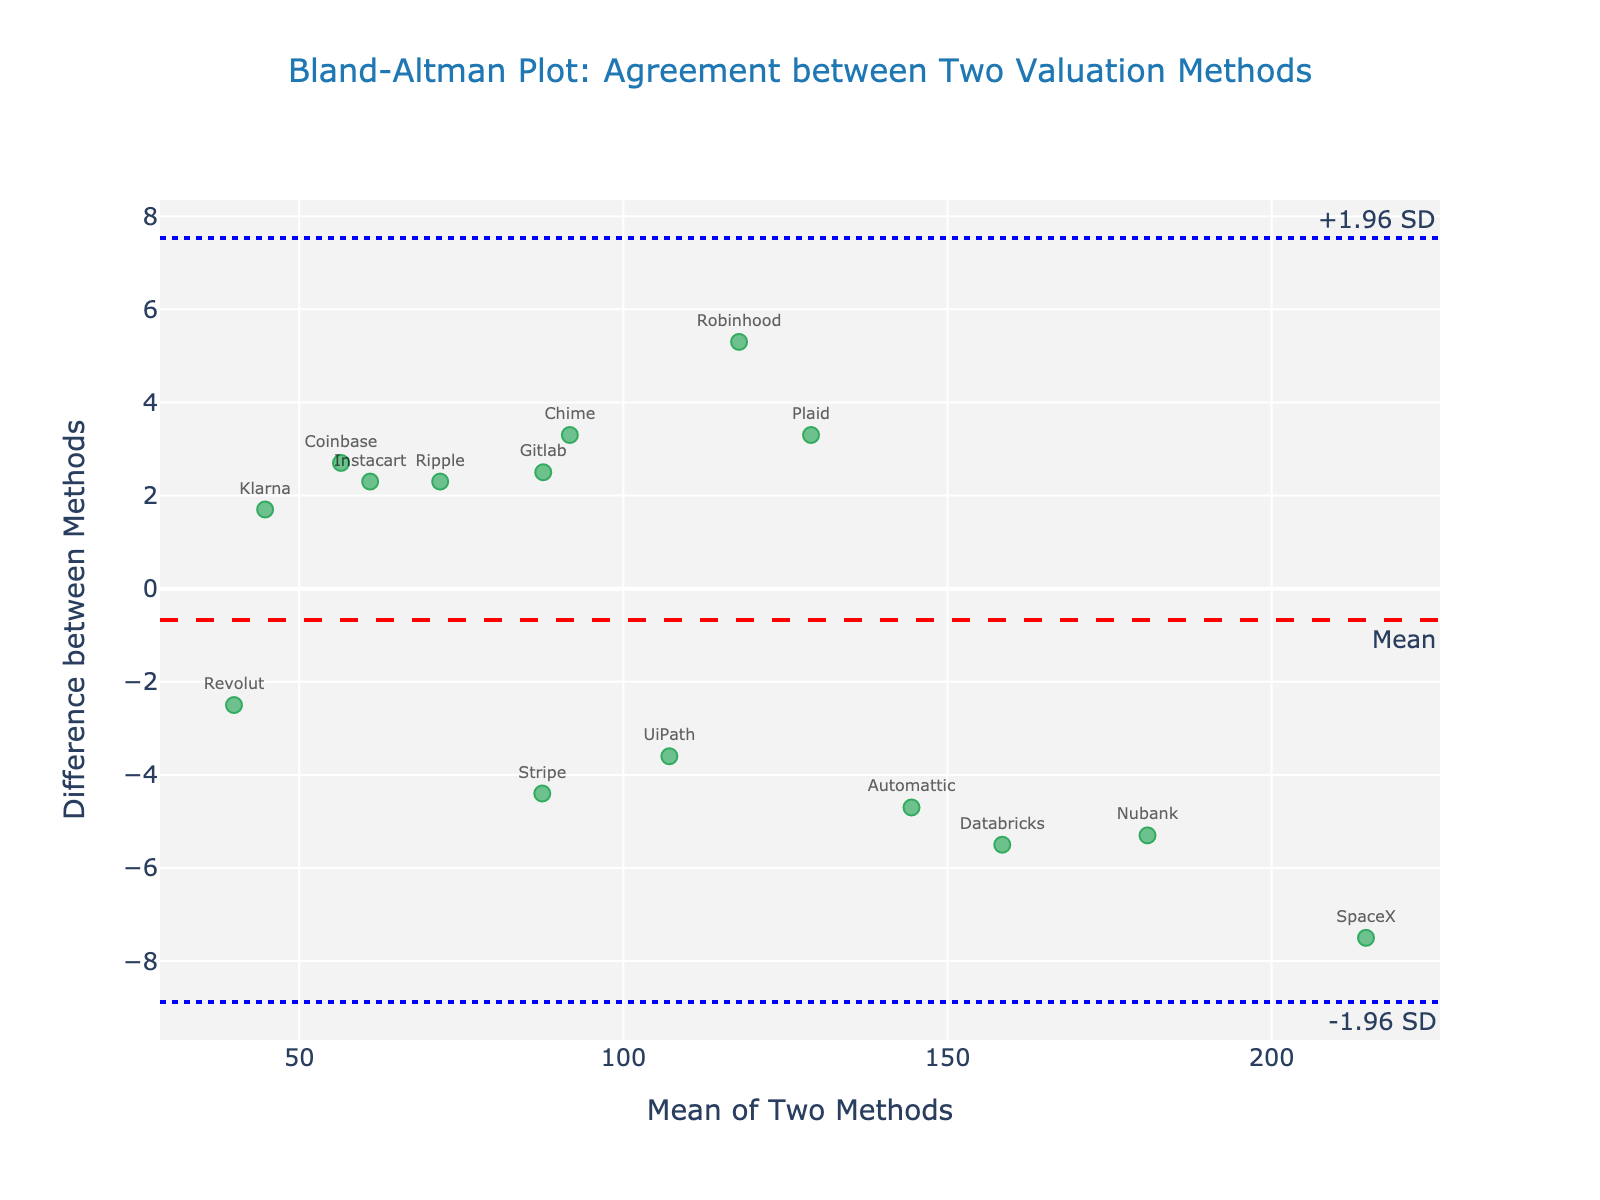What is the title of the plot? The title is located at the top of the plot, describing the purpose or nature of the visualized data. The title is: "Bland-Altman Plot: Agreement between Two Valuation Methods"
Answer: Bland-Altman Plot: Agreement between Two Valuation Methods How many data points are visualized in the plot? Each data point is represented as a marker with a company name label. Counting these markers gives the number of data points. There are 15 companies listed in the data.
Answer: 15 What is the mean difference between the two methods for valuing companies? This information is usually indicated by a dashed red horizontal line annotated with "Mean." The visual placement of this line helps identify the mean difference value, which is around 0.68.
Answer: 0.68 Which company shows the largest positive difference between the two methods? To determine this, find the company with the highest point above the mean difference line. SpaceX has the largest positive difference by visual inspection, as its marker is the highest above the mean difference line.
Answer: SpaceX What are the limits of agreement in this plot? The limits of agreement are usually denoted by dotted blue horizontal lines labeled as "+1.96 SD" and "-1.96 SD." These lines help indicate the range within which most data points should fall. The limits of agreement are approximately (-4.76, 6.12).
Answer: (-4.76, 6.12) Which company has the lowest mean value between the two methods? Look at the x-axis representing the mean of the two methods and find the leftmost data point, which corresponds to the lowest mean value. The company that appears at the lowest mean value is Revolut.
Answer: Revolut What is the range of the mean values between the two methods? The range is found by identifying the minimum and maximum values on the x-axis. The mean values range from about 40 (Revolut) to about 214 (SpaceX).
Answer: 40 to 214 How many companies fall outside the limits of agreement? Count the number of data points that lie above the upper limit of +1.96 SD and below the lower limit of -1.96 SD. These points are outside the agreed range. There are no companies falling outside the limits of agreement.
Answer: 0 What do the limits of agreement indicate about the valuations by the two methods? The limits of agreement illustrate the range in which most differences lie, giving a sense of how the two methods compare. If most data points fall within these limits, it indicates high agreement between the methods.
Answer: High agreement 